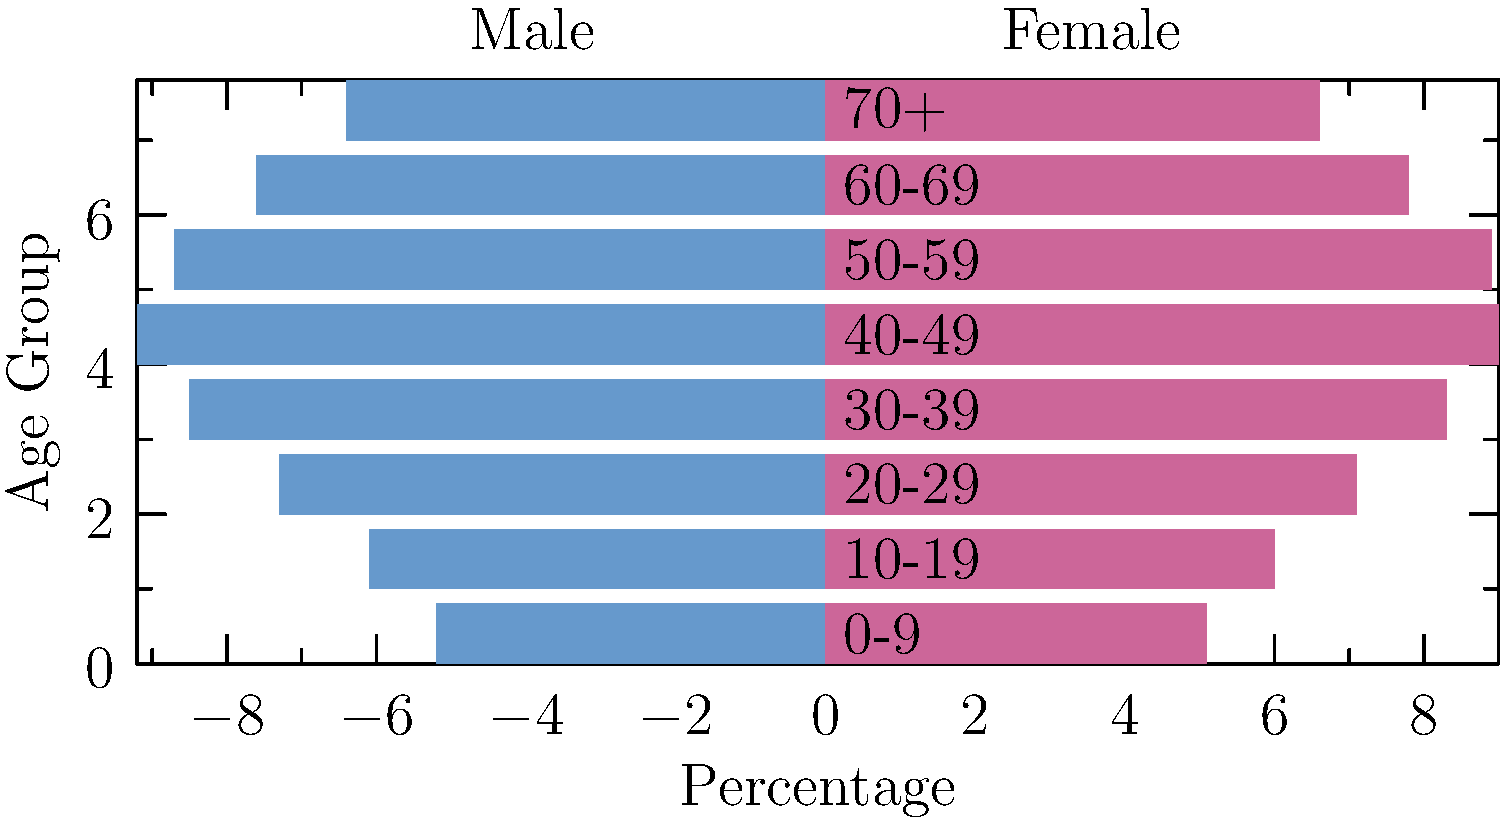As a retired sales manager, you're analyzing customer demographics for a potential new product launch. The population pyramid above represents the age and gender distribution of your target market. Which age group shows the highest combined percentage for both males and females, and what strategy would you recommend to capitalize on this demographic? To answer this question, we need to follow these steps:

1. Analyze the population pyramid:
   - The left side (blue) represents males
   - The right side (pink) represents females
   - Each bar represents a different age group

2. Identify the largest bars for both males and females:
   - For males, the largest bar is in the 40-49 age group
   - For females, the largest bar is also in the 40-49 age group

3. Calculate the combined percentage:
   - Male percentage for 40-49: 9.2%
   - Female percentage for 40-49: 9.0%
   - Combined percentage: 9.2% + 9.0% = 18.2%

4. Confirm this is the highest combined percentage:
   - Check other age groups to ensure none have a higher combined percentage
   - The 40-49 age group indeed has the highest combined percentage

5. Develop a strategy to capitalize on this demographic:
   - Focus marketing efforts on the 40-49 age group
   - Tailor product features to appeal to this age range
   - Consider the lifestyle and preferences of people in their 40s
   - Develop targeted advertising campaigns for this demographic
   - Explore channels that are popular among this age group

The strategy should emphasize the unique needs and desires of the 40-49 age group, leveraging your sales experience to create compelling messages that resonate with this demographic.
Answer: 40-49 age group; target marketing and product features to appeal to people in their 40s. 